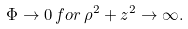<formula> <loc_0><loc_0><loc_500><loc_500>\Phi \rightarrow 0 \, f o r \, \rho ^ { 2 } + z ^ { 2 } \rightarrow \infty .</formula> 